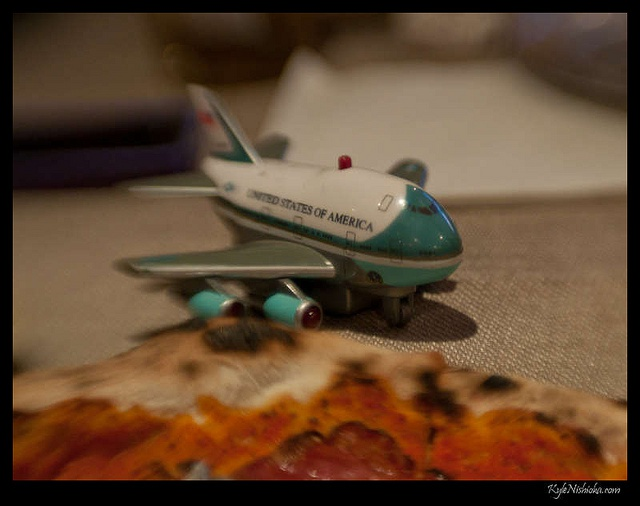Describe the objects in this image and their specific colors. I can see pizza in black, maroon, brown, and gray tones and airplane in black, gray, and tan tones in this image. 